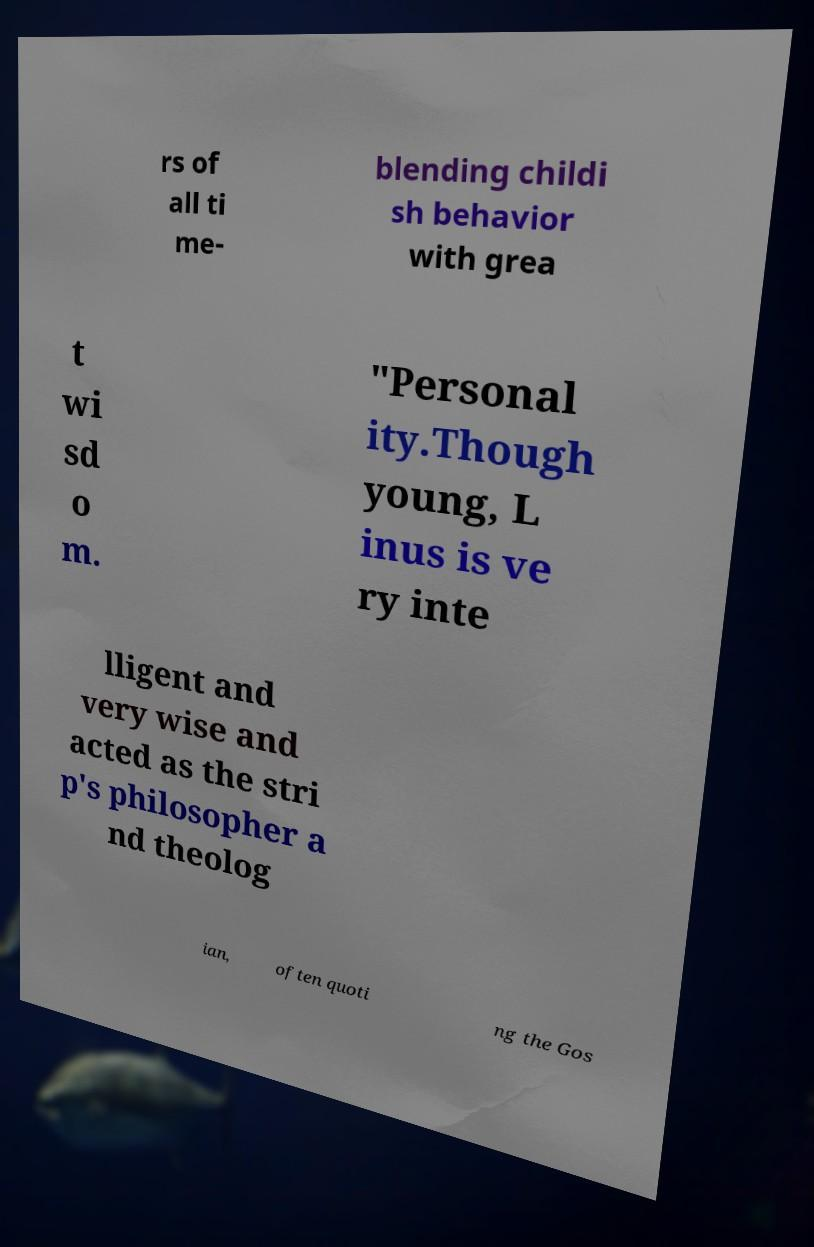I need the written content from this picture converted into text. Can you do that? rs of all ti me- blending childi sh behavior with grea t wi sd o m. "Personal ity.Though young, L inus is ve ry inte lligent and very wise and acted as the stri p's philosopher a nd theolog ian, often quoti ng the Gos 